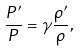<formula> <loc_0><loc_0><loc_500><loc_500>\frac { P ^ { \prime } } { P } = \gamma \frac { \rho ^ { \prime } } { \rho } ,</formula> 